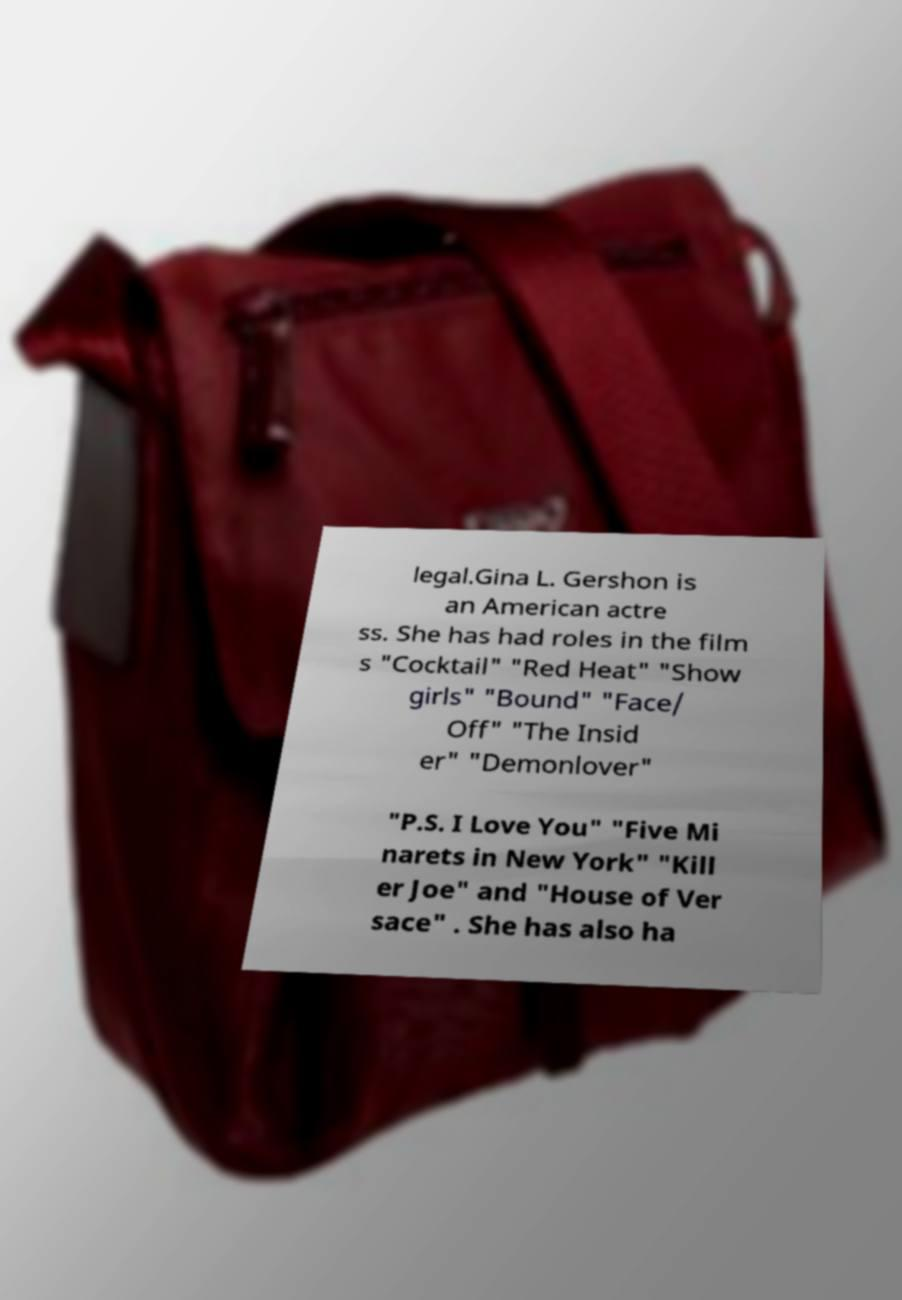I need the written content from this picture converted into text. Can you do that? legal.Gina L. Gershon is an American actre ss. She has had roles in the film s "Cocktail" "Red Heat" "Show girls" "Bound" "Face/ Off" "The Insid er" "Demonlover" "P.S. I Love You" "Five Mi narets in New York" "Kill er Joe" and "House of Ver sace" . She has also ha 